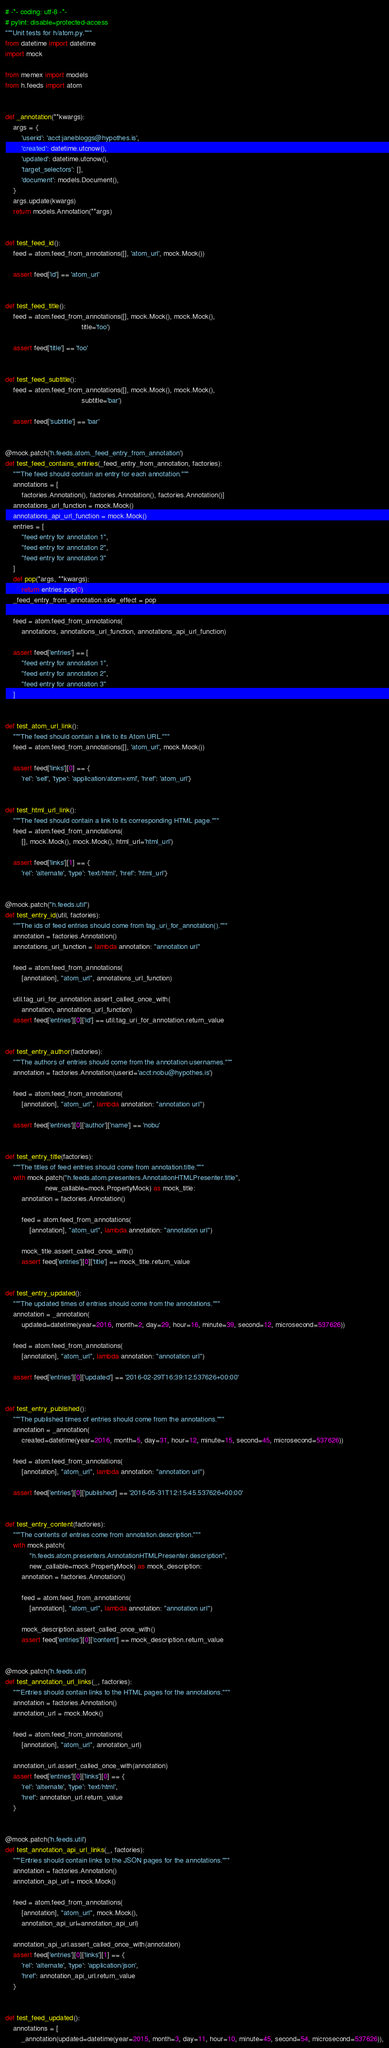<code> <loc_0><loc_0><loc_500><loc_500><_Python_># -*- coding: utf-8 -*-
# pylint: disable=protected-access
"""Unit tests for h/atom.py."""
from datetime import datetime
import mock

from memex import models
from h.feeds import atom


def _annotation(**kwargs):
    args = {
        'userid': 'acct:janebloggs@hypothes.is',
        'created': datetime.utcnow(),
        'updated': datetime.utcnow(),
        'target_selectors': [],
        'document': models.Document(),
    }
    args.update(kwargs)
    return models.Annotation(**args)


def test_feed_id():
    feed = atom.feed_from_annotations([], 'atom_url', mock.Mock())

    assert feed['id'] == 'atom_url'


def test_feed_title():
    feed = atom.feed_from_annotations([], mock.Mock(), mock.Mock(),
                                      title='foo')

    assert feed['title'] == 'foo'


def test_feed_subtitle():
    feed = atom.feed_from_annotations([], mock.Mock(), mock.Mock(),
                                      subtitle='bar')

    assert feed['subtitle'] == 'bar'


@mock.patch('h.feeds.atom._feed_entry_from_annotation')
def test_feed_contains_entries(_feed_entry_from_annotation, factories):
    """The feed should contain an entry for each annotation."""
    annotations = [
        factories.Annotation(), factories.Annotation(), factories.Annotation()]
    annotations_url_function = mock.Mock()
    annotations_api_url_function = mock.Mock()
    entries = [
        "feed entry for annotation 1",
        "feed entry for annotation 2",
        "feed entry for annotation 3"
    ]
    def pop(*args, **kwargs):
        return entries.pop(0)
    _feed_entry_from_annotation.side_effect = pop

    feed = atom.feed_from_annotations(
        annotations, annotations_url_function, annotations_api_url_function)

    assert feed['entries'] == [
        "feed entry for annotation 1",
        "feed entry for annotation 2",
        "feed entry for annotation 3"
    ]


def test_atom_url_link():
    """The feed should contain a link to its Atom URL."""
    feed = atom.feed_from_annotations([], 'atom_url', mock.Mock())

    assert feed['links'][0] == {
        'rel': 'self', 'type': 'application/atom+xml', 'href': 'atom_url'}


def test_html_url_link():
    """The feed should contain a link to its corresponding HTML page."""
    feed = atom.feed_from_annotations(
        [], mock.Mock(), mock.Mock(), html_url='html_url')

    assert feed['links'][1] == {
        'rel': 'alternate', 'type': 'text/html', 'href': 'html_url'}


@mock.patch("h.feeds.util")
def test_entry_id(util, factories):
    """The ids of feed entries should come from tag_uri_for_annotation()."""
    annotation = factories.Annotation()
    annotations_url_function = lambda annotation: "annotation url"

    feed = atom.feed_from_annotations(
        [annotation], "atom_url", annotations_url_function)

    util.tag_uri_for_annotation.assert_called_once_with(
        annotation, annotations_url_function)
    assert feed['entries'][0]['id'] == util.tag_uri_for_annotation.return_value


def test_entry_author(factories):
    """The authors of entries should come from the annotation usernames."""
    annotation = factories.Annotation(userid='acct:nobu@hypothes.is')

    feed = atom.feed_from_annotations(
        [annotation], "atom_url", lambda annotation: "annotation url")

    assert feed['entries'][0]['author']['name'] == 'nobu'


def test_entry_title(factories):
    """The titles of feed entries should come from annotation.title."""
    with mock.patch("h.feeds.atom.presenters.AnnotationHTMLPresenter.title",
                    new_callable=mock.PropertyMock) as mock_title:
        annotation = factories.Annotation()

        feed = atom.feed_from_annotations(
            [annotation], "atom_url", lambda annotation: "annotation url")

        mock_title.assert_called_once_with()
        assert feed['entries'][0]['title'] == mock_title.return_value


def test_entry_updated():
    """The updated times of entries should come from the annotations."""
    annotation = _annotation(
        updated=datetime(year=2016, month=2, day=29, hour=16, minute=39, second=12, microsecond=537626))

    feed = atom.feed_from_annotations(
        [annotation], "atom_url", lambda annotation: "annotation url")

    assert feed['entries'][0]['updated'] == '2016-02-29T16:39:12.537626+00:00'


def test_entry_published():
    """The published times of entries should come from the annotations."""
    annotation = _annotation(
        created=datetime(year=2016, month=5, day=31, hour=12, minute=15, second=45, microsecond=537626))

    feed = atom.feed_from_annotations(
        [annotation], "atom_url", lambda annotation: "annotation url")

    assert feed['entries'][0]['published'] == '2016-05-31T12:15:45.537626+00:00'


def test_entry_content(factories):
    """The contents of entries come from annotation.description."""
    with mock.patch(
            "h.feeds.atom.presenters.AnnotationHTMLPresenter.description",
            new_callable=mock.PropertyMock) as mock_description:
        annotation = factories.Annotation()

        feed = atom.feed_from_annotations(
            [annotation], "atom_url", lambda annotation: "annotation url")

        mock_description.assert_called_once_with()
        assert feed['entries'][0]['content'] == mock_description.return_value


@mock.patch('h.feeds.util')
def test_annotation_url_links(_, factories):
    """Entries should contain links to the HTML pages for the annotations."""
    annotation = factories.Annotation()
    annotation_url = mock.Mock()

    feed = atom.feed_from_annotations(
        [annotation], "atom_url", annotation_url)

    annotation_url.assert_called_once_with(annotation)
    assert feed['entries'][0]['links'][0] == {
        'rel': 'alternate', 'type': 'text/html',
        'href': annotation_url.return_value
    }


@mock.patch('h.feeds.util')
def test_annotation_api_url_links(_, factories):
    """Entries should contain links to the JSON pages for the annotations."""
    annotation = factories.Annotation()
    annotation_api_url = mock.Mock()

    feed = atom.feed_from_annotations(
        [annotation], "atom_url", mock.Mock(),
        annotation_api_url=annotation_api_url)

    annotation_api_url.assert_called_once_with(annotation)
    assert feed['entries'][0]['links'][1] == {
        'rel': 'alternate', 'type': 'application/json',
        'href': annotation_api_url.return_value
    }


def test_feed_updated():
    annotations = [
        _annotation(updated=datetime(year=2015, month=3, day=11, hour=10, minute=45, second=54, microsecond=537626)),</code> 